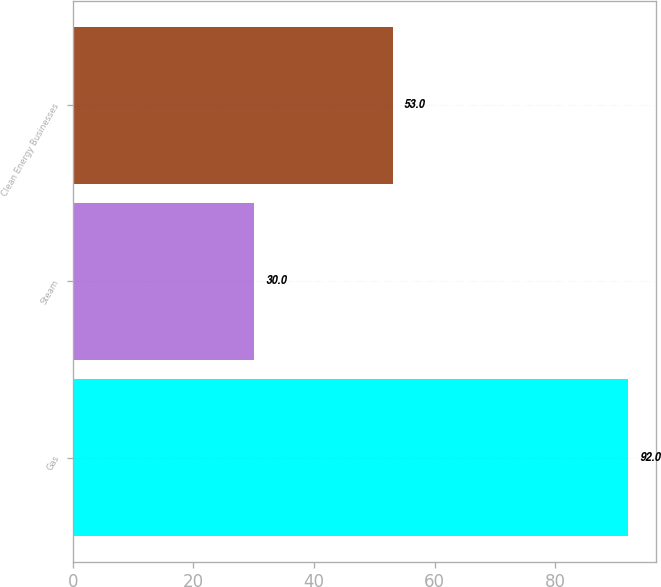Convert chart to OTSL. <chart><loc_0><loc_0><loc_500><loc_500><bar_chart><fcel>Gas<fcel>Steam<fcel>Clean Energy Businesses<nl><fcel>92<fcel>30<fcel>53<nl></chart> 